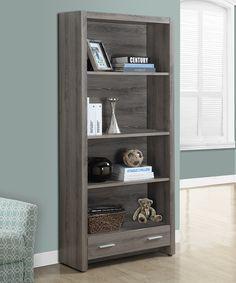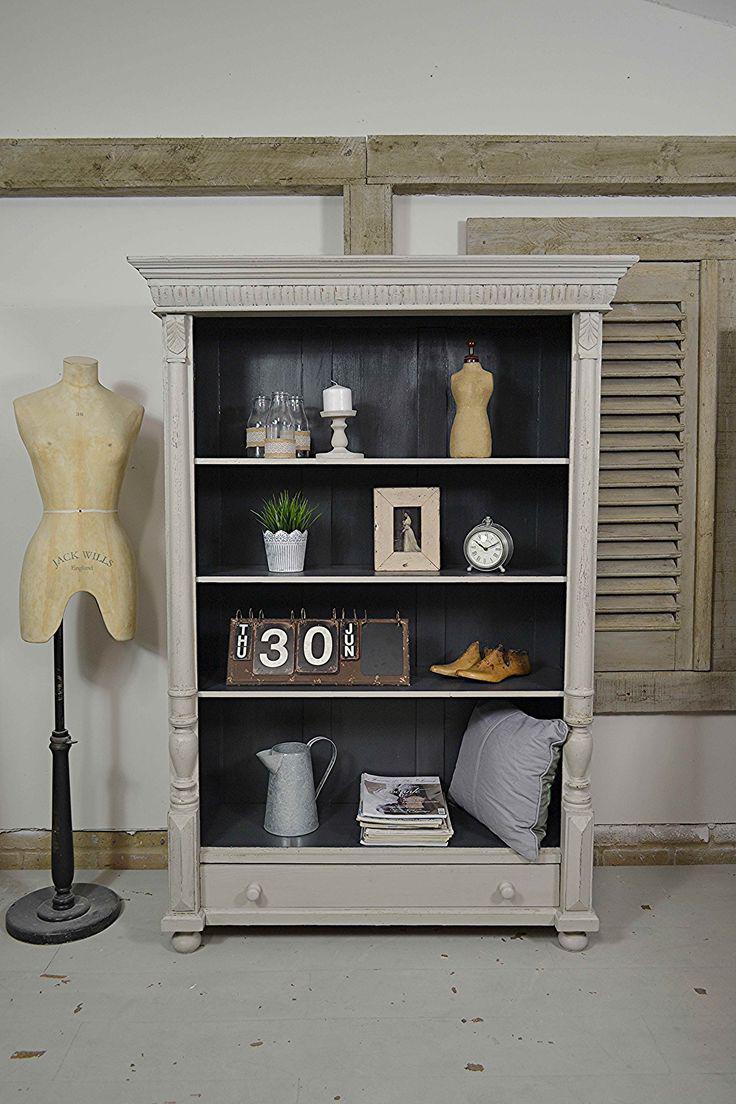The first image is the image on the left, the second image is the image on the right. Assess this claim about the two images: "An image shows a four-shelf cabinet with a blue and white color scheme and plank wood back.". Correct or not? Answer yes or no. No. The first image is the image on the left, the second image is the image on the right. For the images shown, is this caption "One of the images contains a book shelf that is blue and white." true? Answer yes or no. No. 